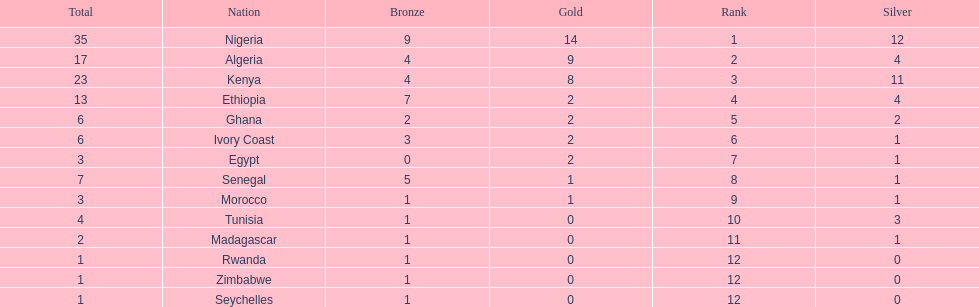The team before algeria Nigeria. 